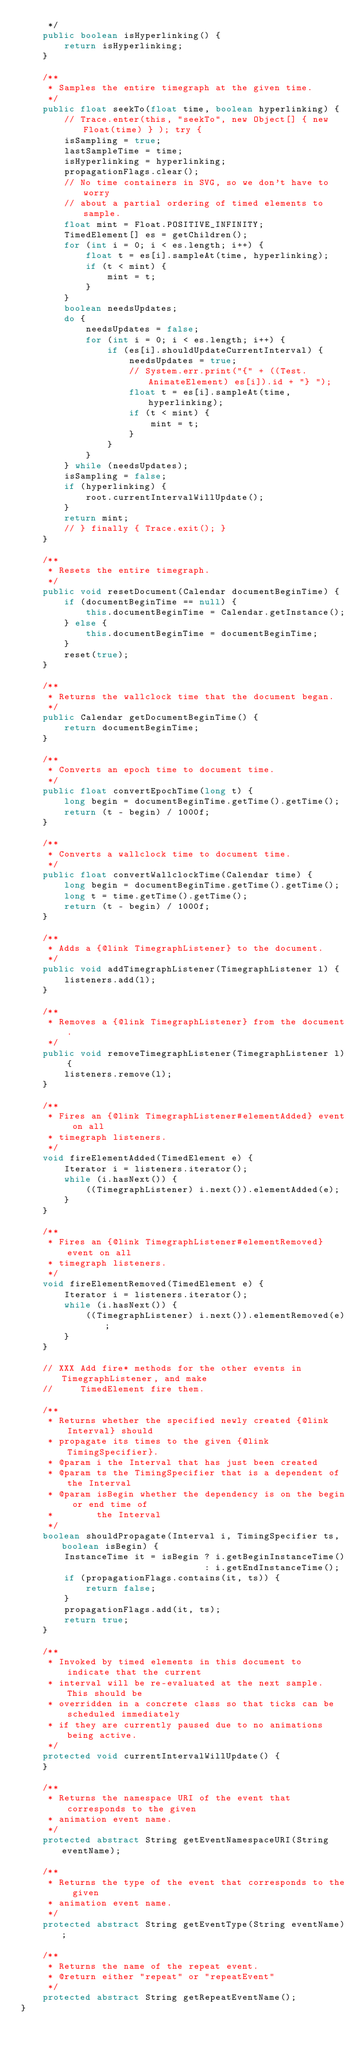<code> <loc_0><loc_0><loc_500><loc_500><_Java_>     */
    public boolean isHyperlinking() {
        return isHyperlinking;
    }

    /**
     * Samples the entire timegraph at the given time.
     */
    public float seekTo(float time, boolean hyperlinking) {
        // Trace.enter(this, "seekTo", new Object[] { new Float(time) } ); try {
        isSampling = true;
        lastSampleTime = time;
        isHyperlinking = hyperlinking;
        propagationFlags.clear();
        // No time containers in SVG, so we don't have to worry
        // about a partial ordering of timed elements to sample.
        float mint = Float.POSITIVE_INFINITY;
        TimedElement[] es = getChildren();
        for (int i = 0; i < es.length; i++) {
            float t = es[i].sampleAt(time, hyperlinking);
            if (t < mint) {
                mint = t;
            }
        }
        boolean needsUpdates;
        do {
            needsUpdates = false;
            for (int i = 0; i < es.length; i++) {
                if (es[i].shouldUpdateCurrentInterval) {
                    needsUpdates = true;
                    // System.err.print("{" + ((Test.AnimateElement) es[i]).id + "} ");
                    float t = es[i].sampleAt(time, hyperlinking);
                    if (t < mint) {
                        mint = t;
                    }
                }
            }
        } while (needsUpdates);
        isSampling = false;
        if (hyperlinking) {
            root.currentIntervalWillUpdate();
        }
        return mint;
        // } finally { Trace.exit(); }
    }

    /**
     * Resets the entire timegraph.
     */
    public void resetDocument(Calendar documentBeginTime) {
        if (documentBeginTime == null) {
            this.documentBeginTime = Calendar.getInstance();
        } else {
            this.documentBeginTime = documentBeginTime;
        }
        reset(true);
    }

    /**
     * Returns the wallclock time that the document began.
     */
    public Calendar getDocumentBeginTime() {
        return documentBeginTime;
    }

    /**
     * Converts an epoch time to document time.
     */
    public float convertEpochTime(long t) {
        long begin = documentBeginTime.getTime().getTime();
        return (t - begin) / 1000f;
    }

    /**
     * Converts a wallclock time to document time.
     */
    public float convertWallclockTime(Calendar time) {
        long begin = documentBeginTime.getTime().getTime();
        long t = time.getTime().getTime();
        return (t - begin) / 1000f;
    }

    /**
     * Adds a {@link TimegraphListener} to the document.
     */
    public void addTimegraphListener(TimegraphListener l) {
        listeners.add(l);
    }

    /**
     * Removes a {@link TimegraphListener} from the document.
     */
    public void removeTimegraphListener(TimegraphListener l) {
        listeners.remove(l);
    }

    /**
     * Fires an {@link TimegraphListener#elementAdded} event on all
     * timegraph listeners.
     */
    void fireElementAdded(TimedElement e) {
        Iterator i = listeners.iterator();
        while (i.hasNext()) {
            ((TimegraphListener) i.next()).elementAdded(e);
        }
    }

    /**
     * Fires an {@link TimegraphListener#elementRemoved} event on all
     * timegraph listeners.
     */
    void fireElementRemoved(TimedElement e) {
        Iterator i = listeners.iterator();
        while (i.hasNext()) {
            ((TimegraphListener) i.next()).elementRemoved(e);
        }
    }

    // XXX Add fire* methods for the other events in TimegraphListener, and make
    //     TimedElement fire them.

    /**
     * Returns whether the specified newly created {@link Interval} should 
     * propagate its times to the given {@link TimingSpecifier}.
     * @param i the Interval that has just been created
     * @param ts the TimingSpecifier that is a dependent of the Interval
     * @param isBegin whether the dependency is on the begin or end time of
     *        the Interval
     */
    boolean shouldPropagate(Interval i, TimingSpecifier ts, boolean isBegin) {
        InstanceTime it = isBegin ? i.getBeginInstanceTime()
                                  : i.getEndInstanceTime();
        if (propagationFlags.contains(it, ts)) {
            return false;
        }
        propagationFlags.add(it, ts);
        return true;
    }

    /**
     * Invoked by timed elements in this document to indicate that the current
     * interval will be re-evaluated at the next sample.  This should be
     * overridden in a concrete class so that ticks can be scheduled immediately
     * if they are currently paused due to no animations being active.
     */
    protected void currentIntervalWillUpdate() {
    }

    /**
     * Returns the namespace URI of the event that corresponds to the given
     * animation event name.
     */
    protected abstract String getEventNamespaceURI(String eventName);

    /**
     * Returns the type of the event that corresponds to the given
     * animation event name.
     */
    protected abstract String getEventType(String eventName);

    /**
     * Returns the name of the repeat event.
     * @return either "repeat" or "repeatEvent"
     */
    protected abstract String getRepeatEventName();
}
</code> 